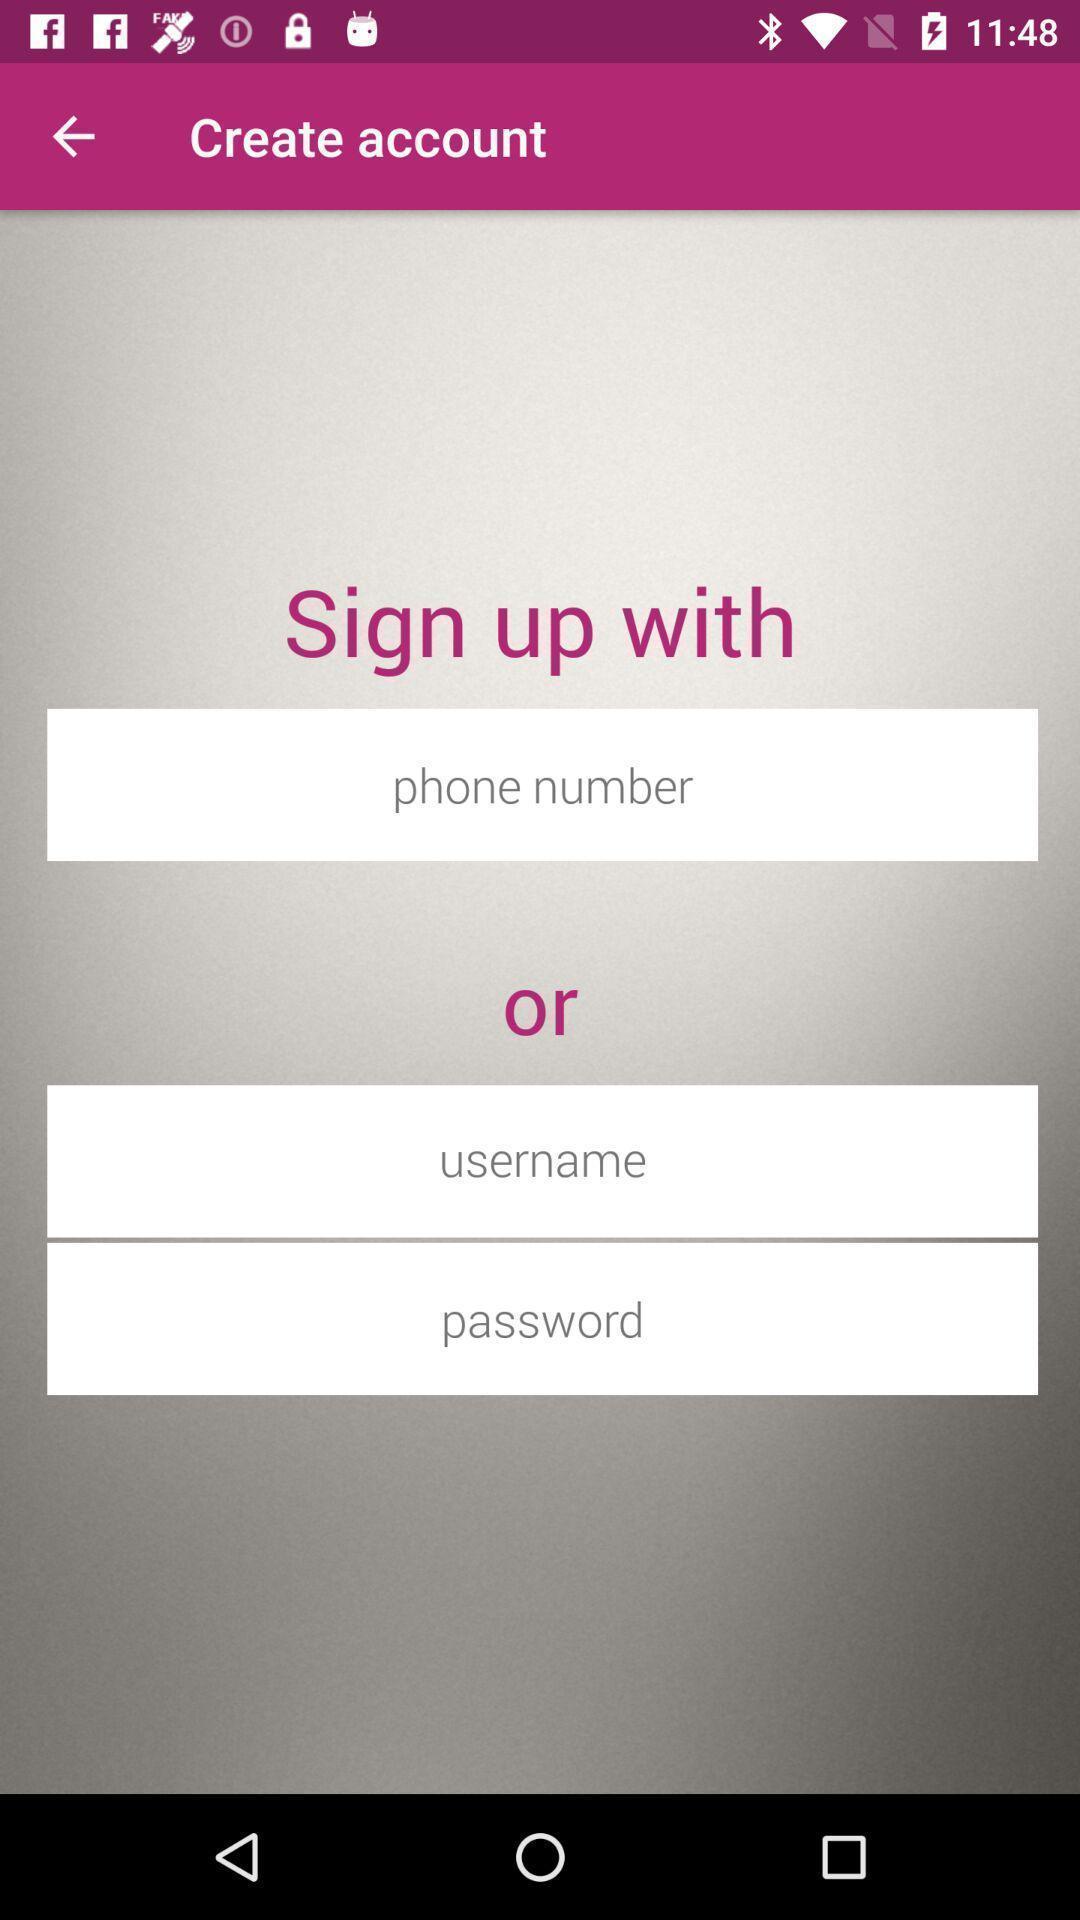Describe this image in words. Sign up page to create an account. 